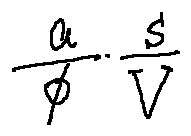Convert formula to latex. <formula><loc_0><loc_0><loc_500><loc_500>\frac { a } { \phi } \frac { s } { V }</formula> 